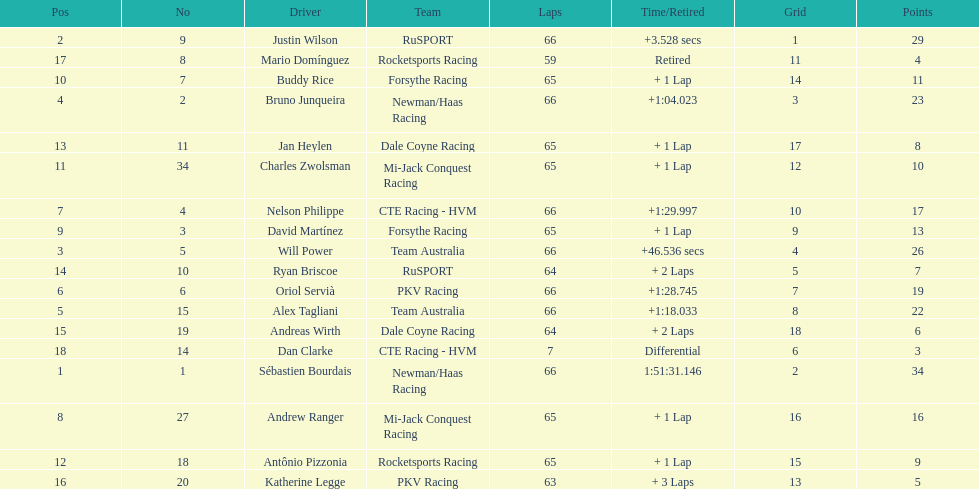At the 2006 gran premio telmex, who finished last? Dan Clarke. 